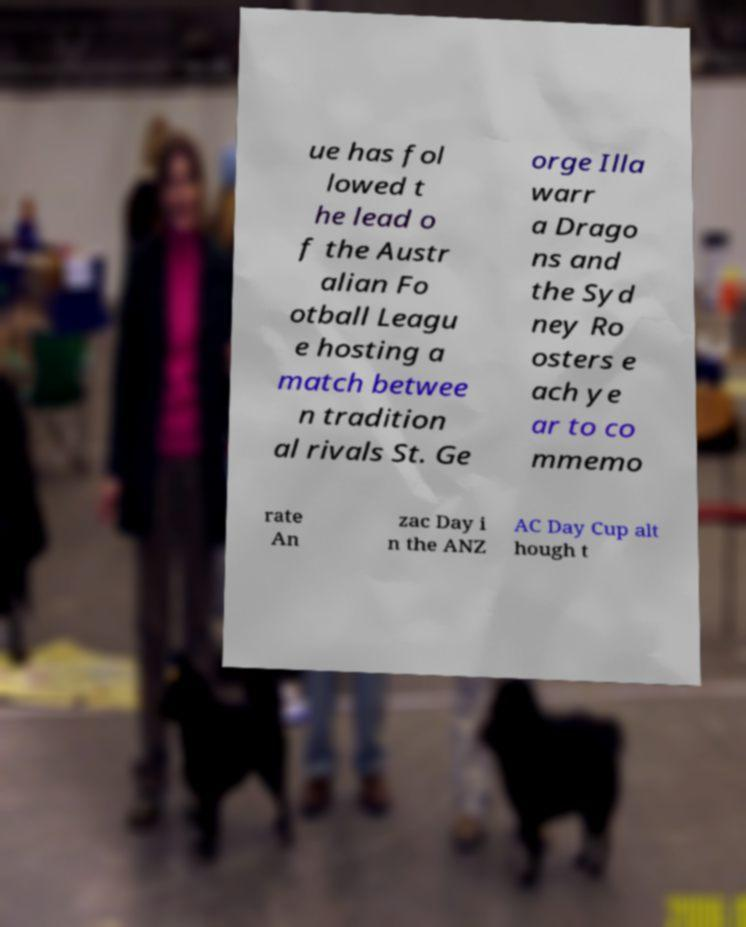Could you extract and type out the text from this image? ue has fol lowed t he lead o f the Austr alian Fo otball Leagu e hosting a match betwee n tradition al rivals St. Ge orge Illa warr a Drago ns and the Syd ney Ro osters e ach ye ar to co mmemo rate An zac Day i n the ANZ AC Day Cup alt hough t 